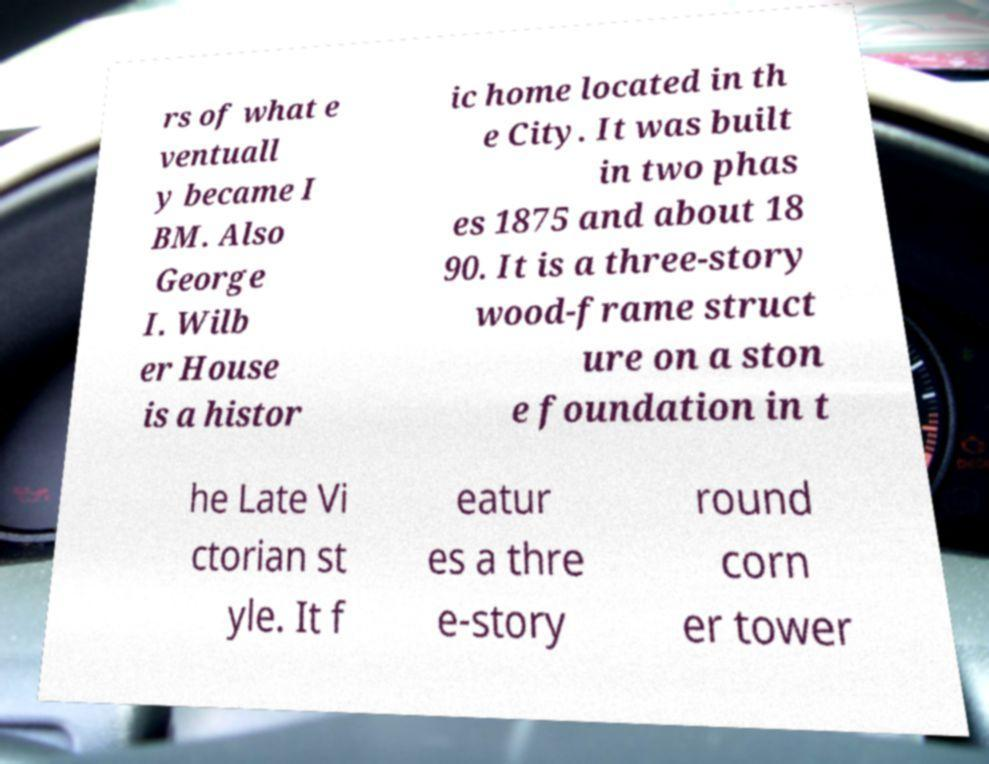What messages or text are displayed in this image? I need them in a readable, typed format. rs of what e ventuall y became I BM. Also George I. Wilb er House is a histor ic home located in th e City. It was built in two phas es 1875 and about 18 90. It is a three-story wood-frame struct ure on a ston e foundation in t he Late Vi ctorian st yle. It f eatur es a thre e-story round corn er tower 